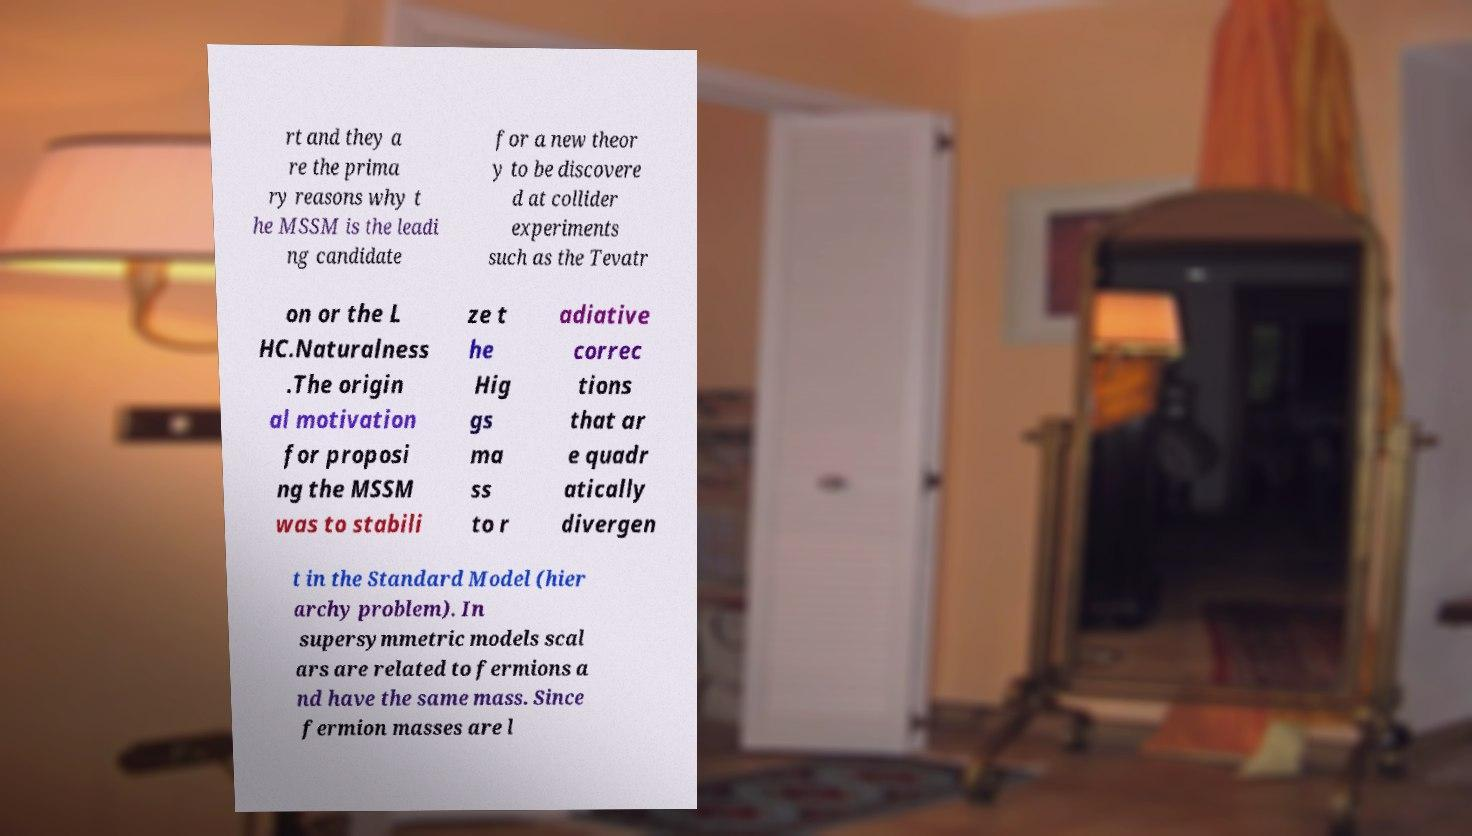For documentation purposes, I need the text within this image transcribed. Could you provide that? rt and they a re the prima ry reasons why t he MSSM is the leadi ng candidate for a new theor y to be discovere d at collider experiments such as the Tevatr on or the L HC.Naturalness .The origin al motivation for proposi ng the MSSM was to stabili ze t he Hig gs ma ss to r adiative correc tions that ar e quadr atically divergen t in the Standard Model (hier archy problem). In supersymmetric models scal ars are related to fermions a nd have the same mass. Since fermion masses are l 